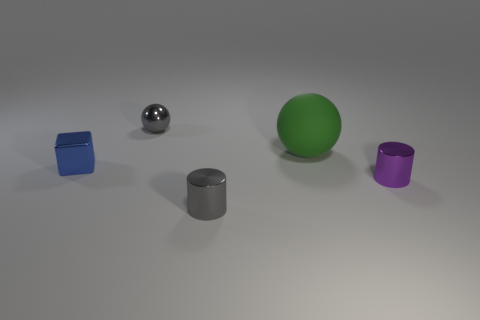What is the color of the large rubber ball? The large rubber ball in the image is a vibrant shade of green, standing out amid the other objects. 